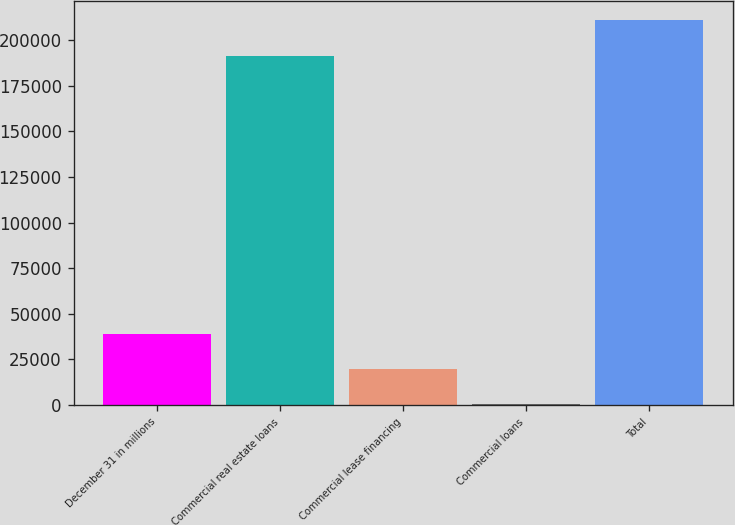<chart> <loc_0><loc_0><loc_500><loc_500><bar_chart><fcel>December 31 in millions<fcel>Commercial real estate loans<fcel>Commercial lease financing<fcel>Commercial loans<fcel>Total<nl><fcel>39087.6<fcel>191407<fcel>19715.8<fcel>344<fcel>210779<nl></chart> 